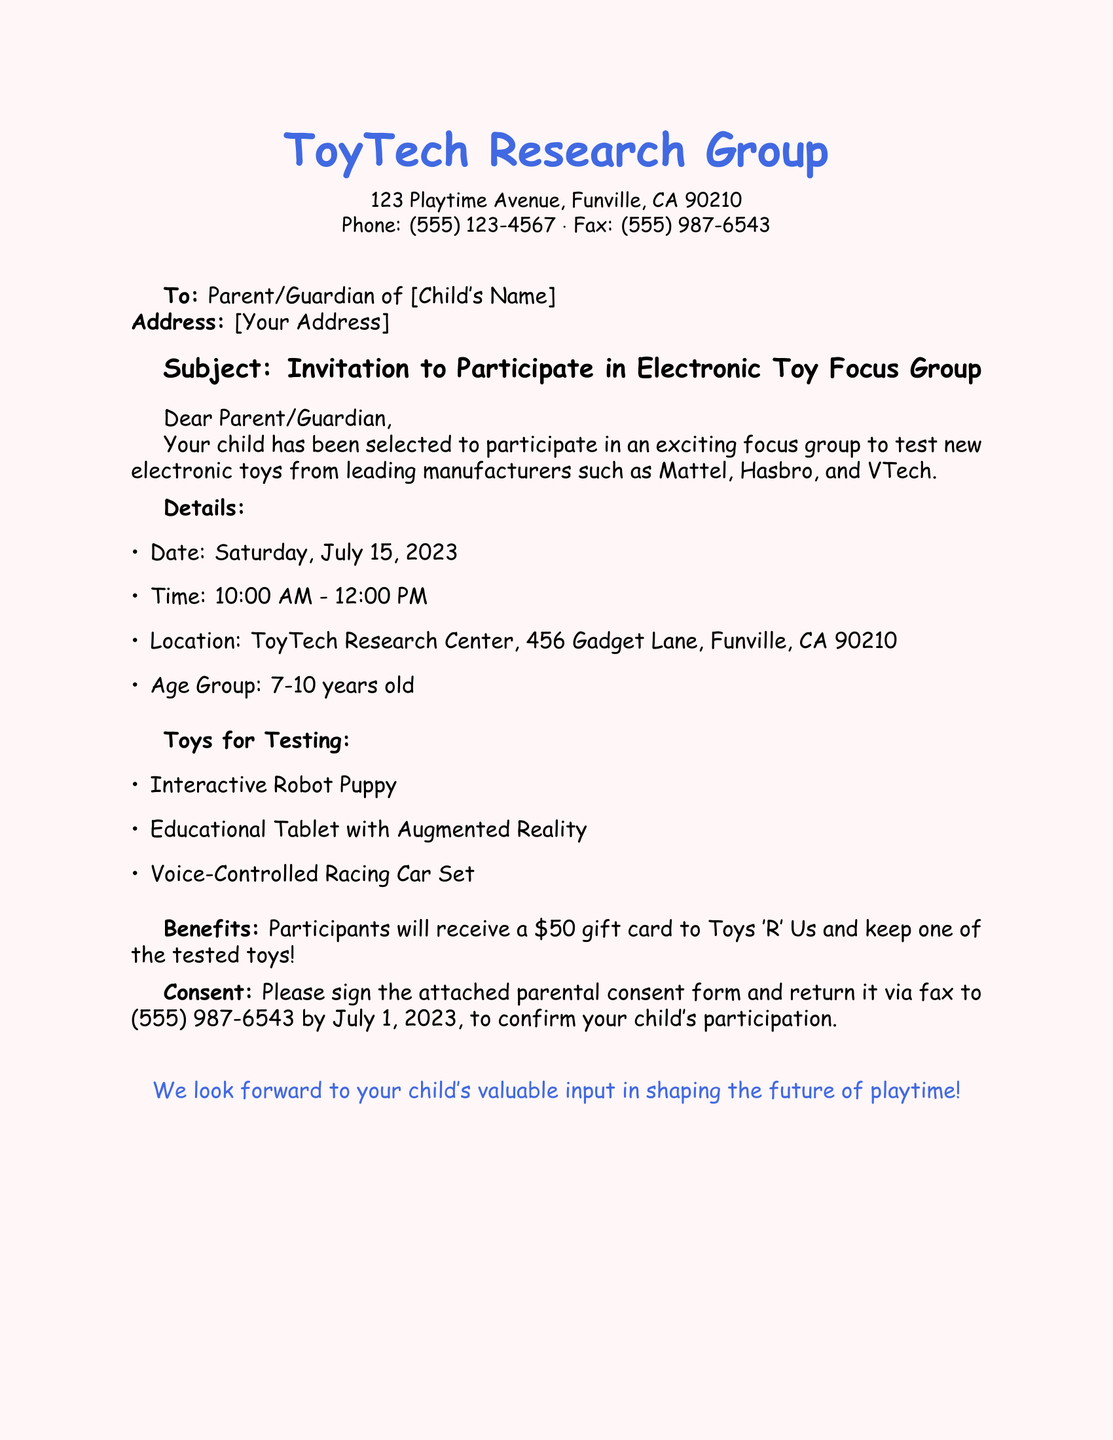What is the name of the organization sending the invitation? The name of the organization is stated at the top of the document.
Answer: ToyTech Research Group What is the date of the focus group? The specific date is mentioned in the details section of the document.
Answer: Saturday, July 15, 2023 What time does the focus group start? The starting time is provided in the schedule section of the document.
Answer: 10:00 AM How much is the gift card for participants? The monetary amount for the gift card is specified in the benefits section of the document.
Answer: $50 What age group is eligible to participate? The eligible age group is described in the details section of the document.
Answer: 7-10 years old What toy type is not mentioned in the testing list? The types of toys tested are listed, and any not included would not be mentioned.
Answer: None (All types are listed) What is required from the parent to confirm participation? The document mentions a specific action that must be taken for confirmation.
Answer: Sign the parental consent form By what date should the consent form be returned? The deadline for returning the consent form is clearly noted in the consent section.
Answer: July 1, 2023 Where is the focus group located? The location is specified in the details section of the document.
Answer: ToyTech Research Center, 456 Gadget Lane, Funville, CA 90210 